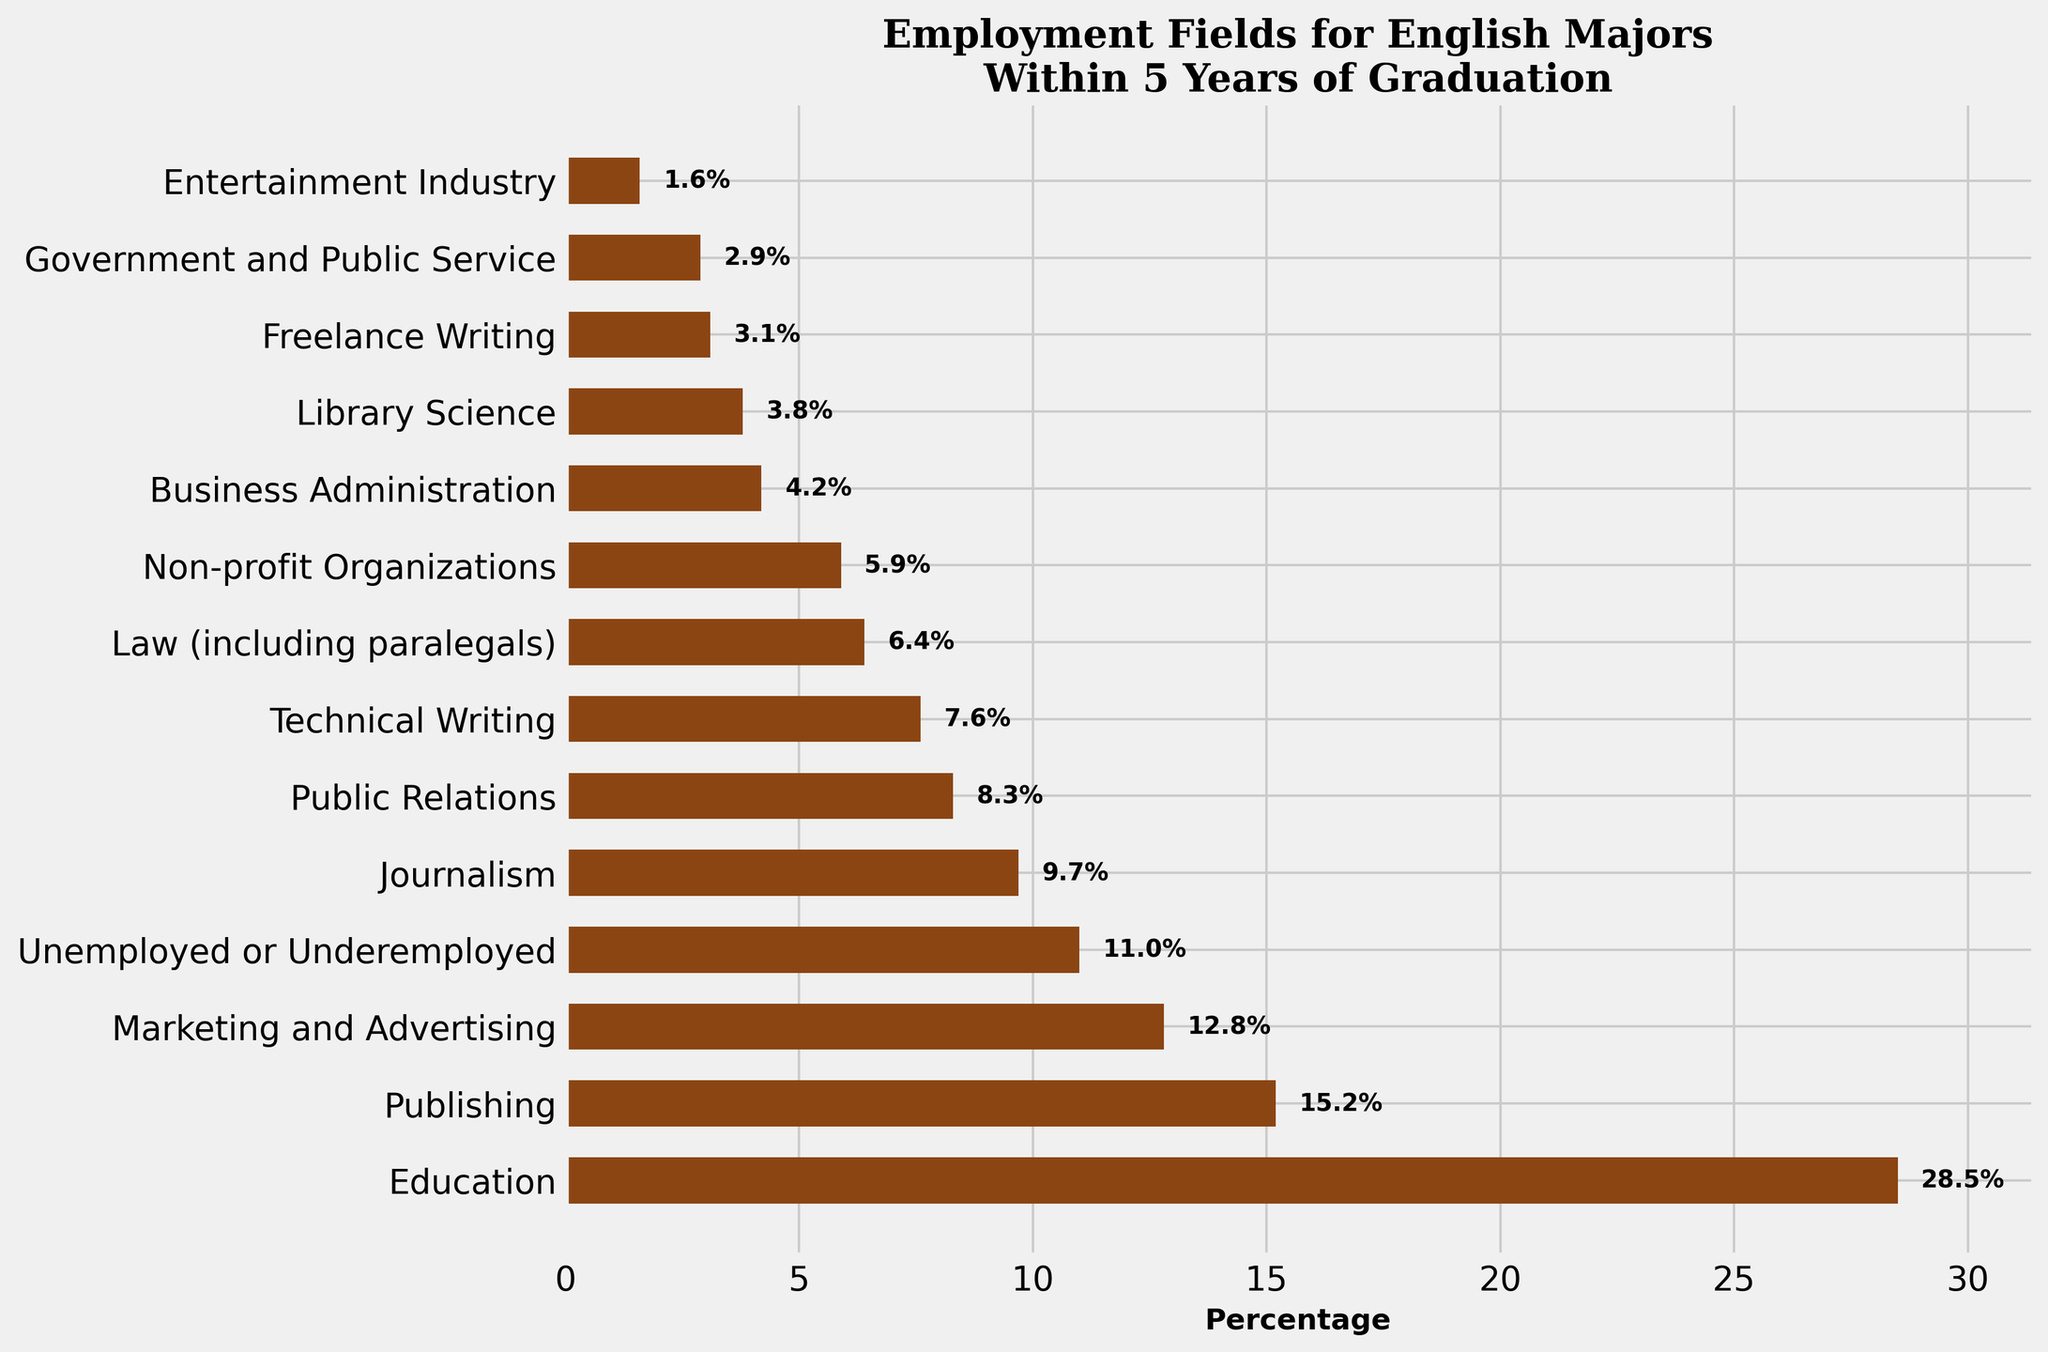Which field has the highest percentage of English majors employed within 5 years of graduation? To find the field with the highest employment percentage, look at the bars and identify the longest one. The field with the highest percentage will have the longest bar.
Answer: Education What's the total percentage of English majors employed in Education and Marketing and Advertising combined? Sum the percentages for Education (28.5) and Marketing and Advertising (12.8). The total is 28.5 + 12.8.
Answer: 41.3 How much greater is the percentage of English majors employed in Publishing compared to Business Administration? Subtract the percentage for Business Administration (4.2) from the percentage for Publishing (15.2). The difference is 15.2 - 4.2.
Answer: 11.0 Which employment field is closest in percentage to English majors who are Unemployed or Underemployed? Compare the percentage of Unemployed or Underemployed (11.0) to other percentages and find the closest one. The closest percentage is Journalists at 9.7.
Answer: Journalism In which field do less than 5% of English majors find employment, based on the chart? Identify bars with percentages less than 5% by looking at the length of the bars relative to the percentage axis. Fields below 5% are Business Administration (4.2), Library Science (3.8), Freelance Writing (3.1), Government and Public Service (2.9), and Entertainment Industry (1.6).
Answer: Business Administration, Library Science, Freelance Writing, Government and Public Service, Entertainment Industry What is the combined percentage of English majors employed in Law and Technical Writing? Add the percentages for Law (6.4) and Technical Writing (7.6). The combined percentage is 6.4 + 7.6.
Answer: 14.0 How does the percentage of English majors employed in Public Relations compare with those in Journalism? Compare the percentages directly: Public Relations (8.3) and Journalism (9.7). Journalists have a higher percentage than Public Relations.
Answer: Journalism has higher What is the median value of the percentages shown in the chart? Arrange the percentages in ascending order and find the middle value. With an odd number (13 values), the middle value is the 7th one: [1.6, 2.9, 3.1, 3.8, 4.2, 5.9, 6.4, 7.6, 8.3, 9.7, 11.0, 12.8, 15.2, 28.5]. So the median is the 7th value, which is 6.4 (Law).
Answer: 6.4 